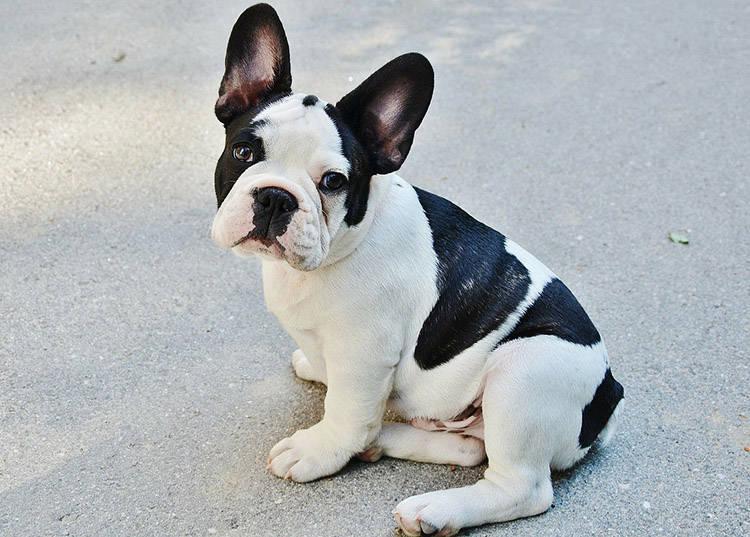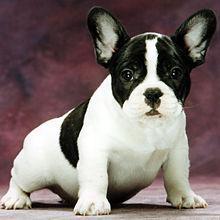The first image is the image on the left, the second image is the image on the right. Analyze the images presented: Is the assertion "Each image shows one sitting dog with black-and-white coloring, at least on its face." valid? Answer yes or no. Yes. 